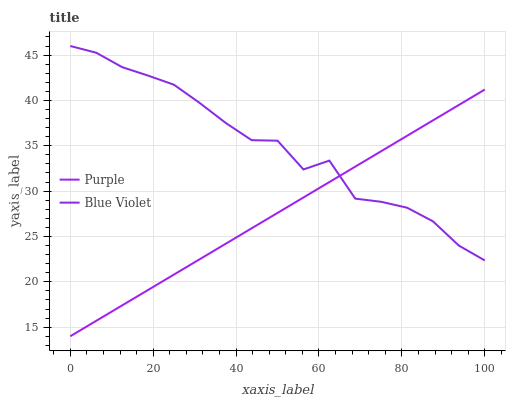Does Purple have the minimum area under the curve?
Answer yes or no. Yes. Does Blue Violet have the maximum area under the curve?
Answer yes or no. Yes. Does Blue Violet have the minimum area under the curve?
Answer yes or no. No. Is Purple the smoothest?
Answer yes or no. Yes. Is Blue Violet the roughest?
Answer yes or no. Yes. Is Blue Violet the smoothest?
Answer yes or no. No. Does Purple have the lowest value?
Answer yes or no. Yes. Does Blue Violet have the lowest value?
Answer yes or no. No. Does Blue Violet have the highest value?
Answer yes or no. Yes. Does Purple intersect Blue Violet?
Answer yes or no. Yes. Is Purple less than Blue Violet?
Answer yes or no. No. Is Purple greater than Blue Violet?
Answer yes or no. No. 